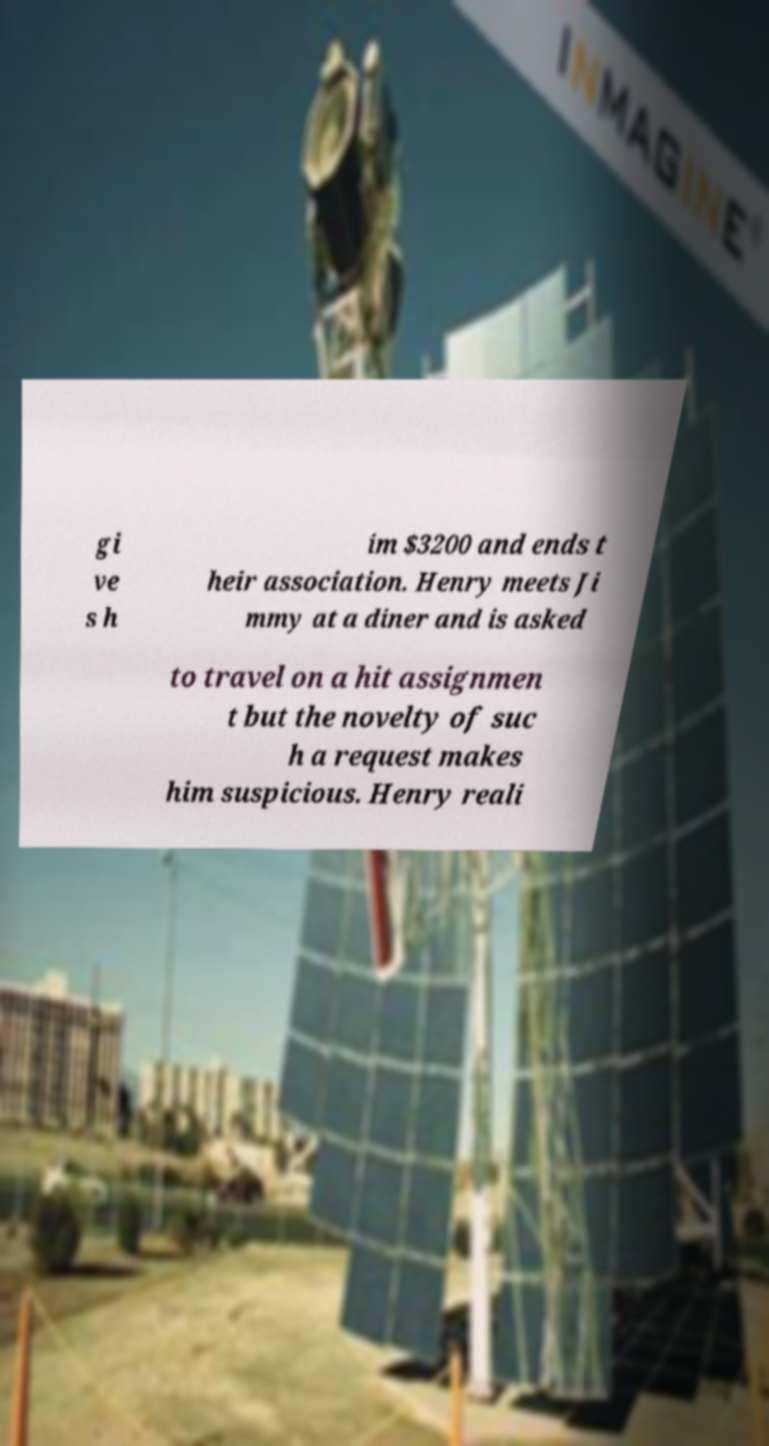Can you read and provide the text displayed in the image?This photo seems to have some interesting text. Can you extract and type it out for me? gi ve s h im $3200 and ends t heir association. Henry meets Ji mmy at a diner and is asked to travel on a hit assignmen t but the novelty of suc h a request makes him suspicious. Henry reali 